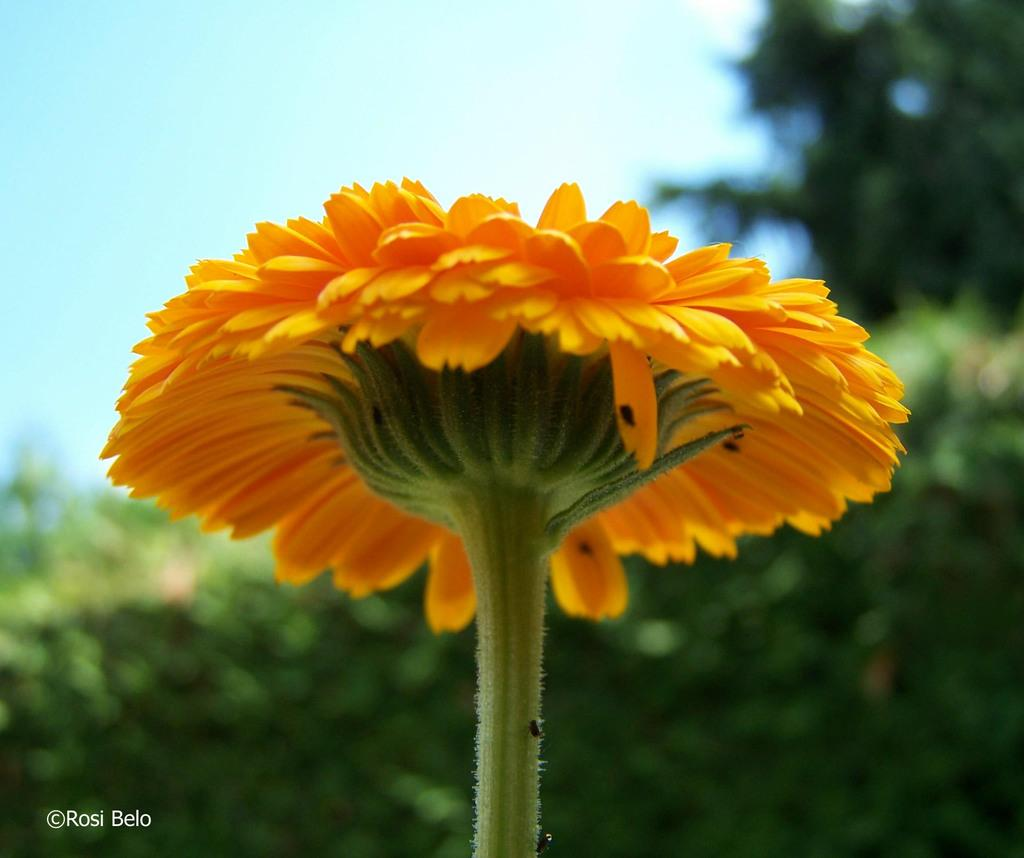What is the main subject of the image? The main subject of the image is a flower. Can you describe the flower in more detail? The flower has a stem and is yellow. What else can be seen in the image besides the flower? There are plants visible in the background of the image. What is the background of the image like? The sky is visible in the background of the image. How many eggs can be seen hanging from the flower in the image? There are no eggs present in the image, and therefore none can be seen hanging from the flower. 